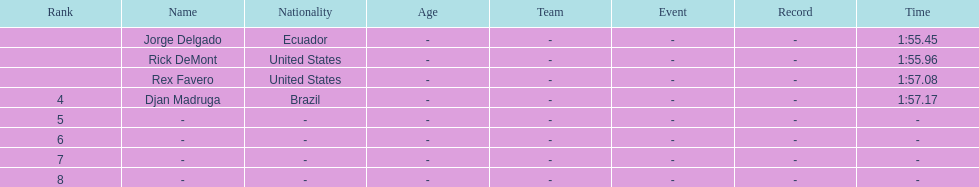Who was the last finisher from the us? Rex Favero. 